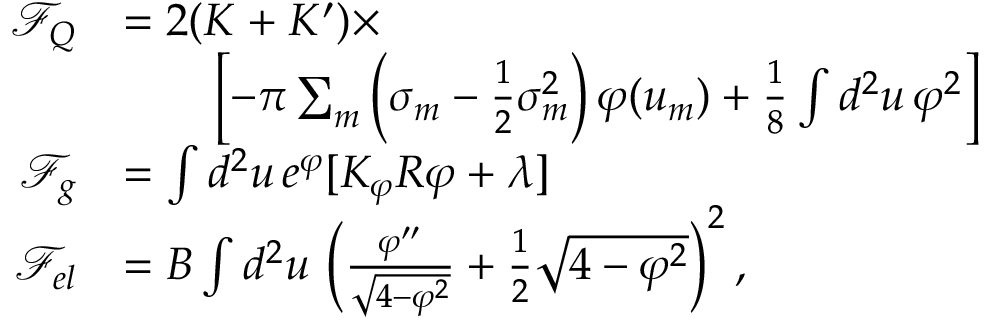<formula> <loc_0><loc_0><loc_500><loc_500>\begin{array} { r l } { \mathcal { F } _ { Q } } & { = 2 ( K + K ^ { \prime } ) \times } \\ & { \quad \left [ - \pi \sum _ { m } \left ( \sigma _ { m } - \frac { 1 } { 2 } \sigma _ { m } ^ { 2 } \right ) \varphi ( u _ { m } ) + \frac { 1 } { 8 } \int d ^ { 2 } u \, \varphi ^ { 2 } \right ] } \\ { \mathcal { F } _ { g } } & { = \int d ^ { 2 } u \, e ^ { \varphi } [ K _ { \varphi } R \varphi + \lambda ] } \\ { \mathcal { F } _ { e l } } & { = B \int d ^ { 2 } u \, \left ( \frac { \varphi ^ { \prime \prime } } { \sqrt { 4 - \varphi ^ { 2 } } } + \frac { 1 } { 2 } \sqrt { 4 - \varphi ^ { 2 } } \right ) ^ { 2 } , } \end{array}</formula> 